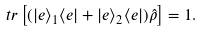<formula> <loc_0><loc_0><loc_500><loc_500>t r \left [ ( | e \rangle _ { 1 } \langle e | + | e \rangle _ { 2 } \langle e | ) \hat { \rho } \right ] = 1 .</formula> 